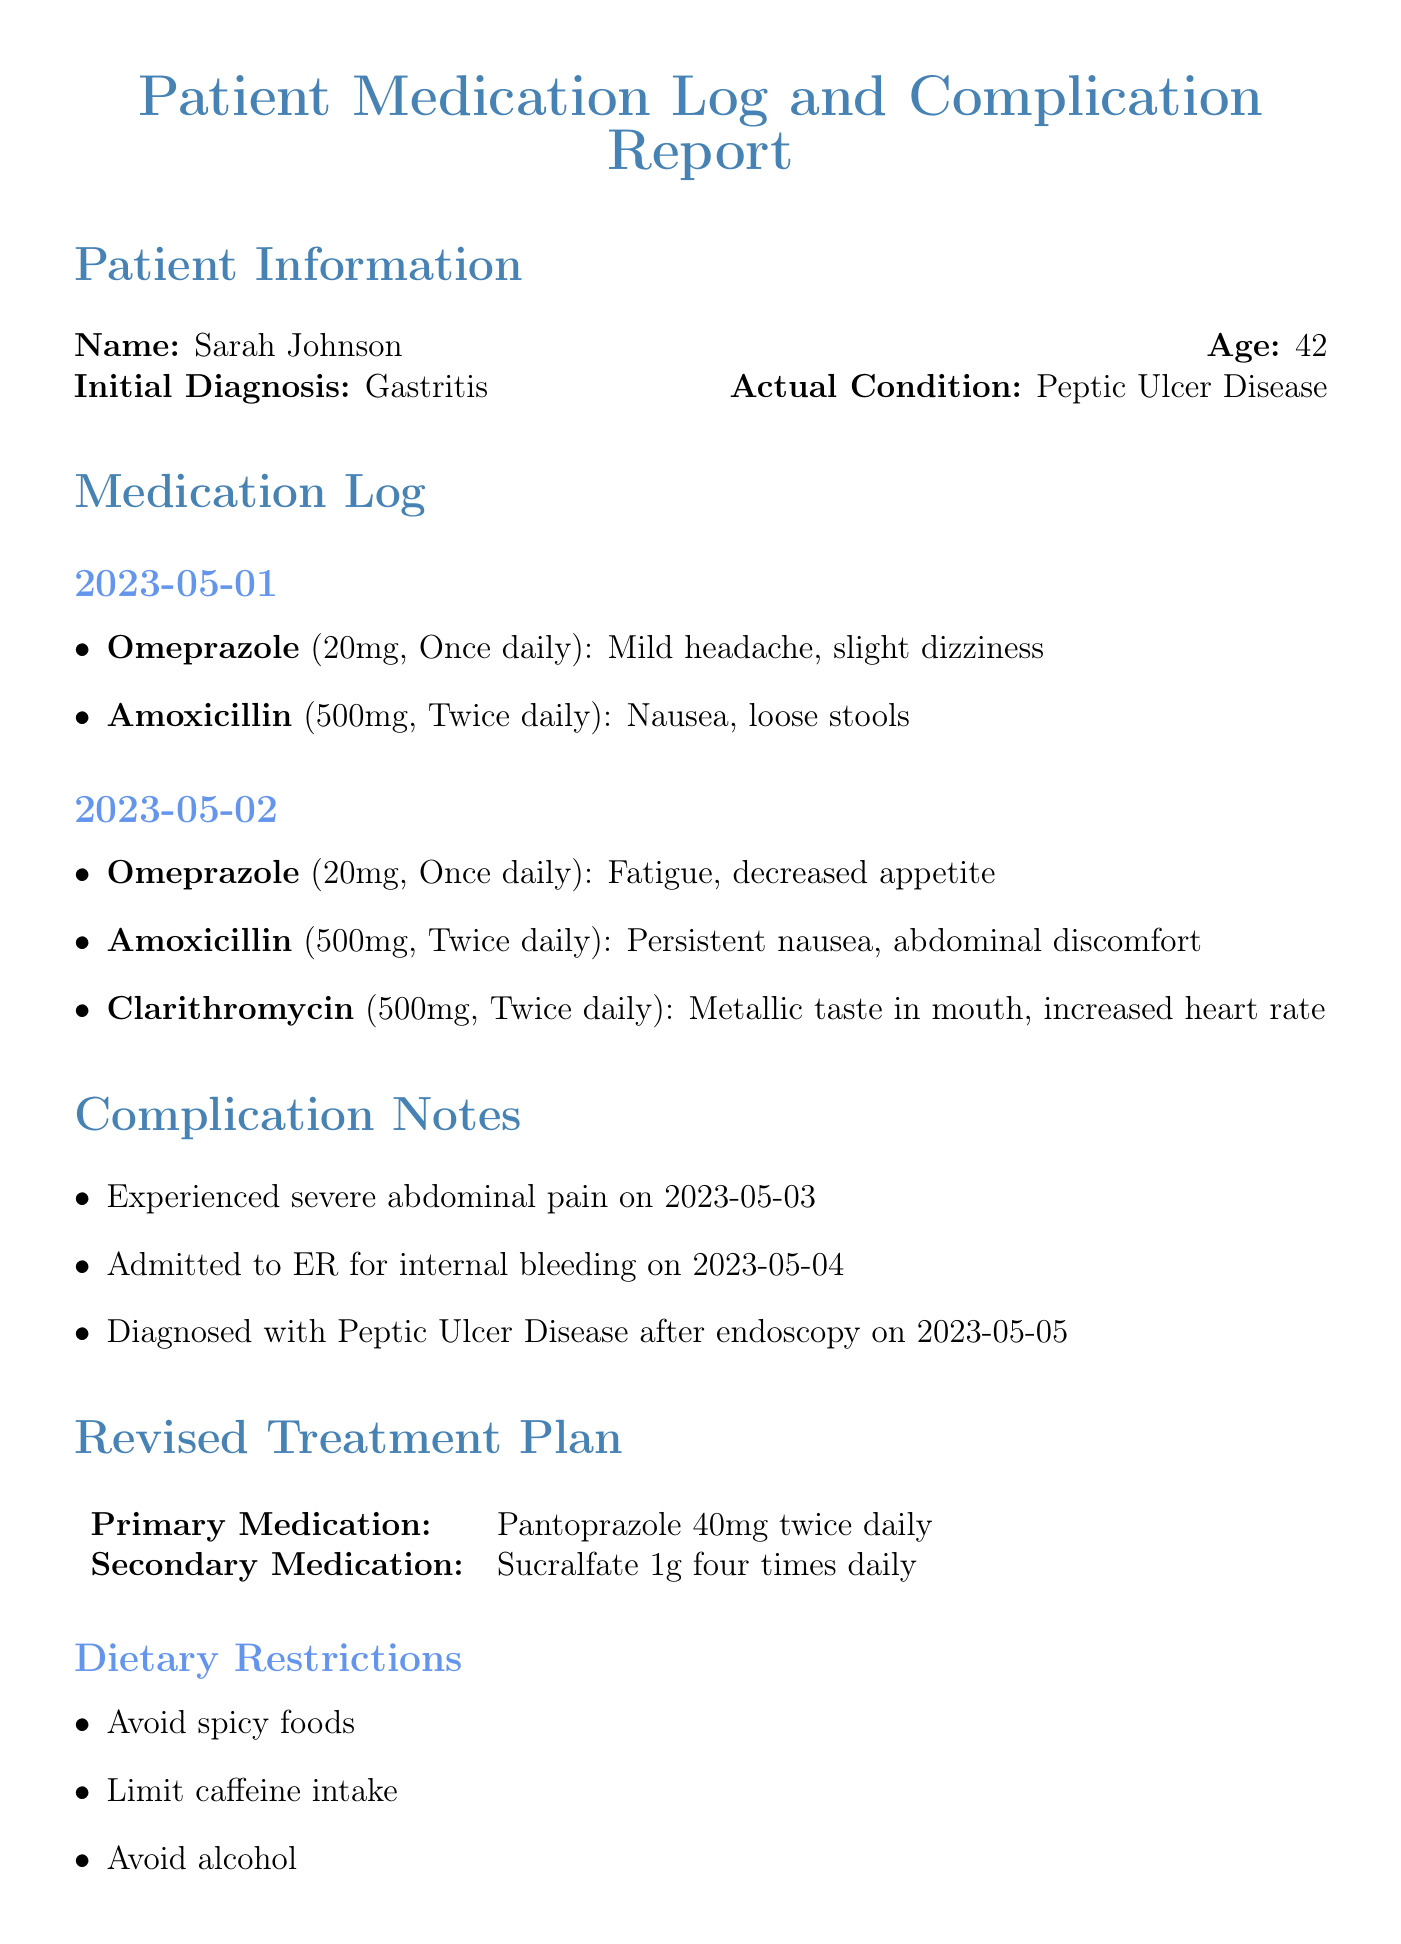What is the name of the patient? The name of the patient is explicitly mentioned in the patient information section.
Answer: Sarah Johnson What condition was the patient initially diagnosed with? The initial diagnosis is stated in the patient information section.
Answer: Gastritis What medication was taken on May 2nd that causes a metallic taste in the mouth? This requires looking at the specific side effects of the medications listed on that date.
Answer: Clarithromycin What date did the patient experience severe abdominal pain? This is found in the complication notes section, explicitly stating the date.
Answer: 2023-05-03 What is the primary medication in the revised treatment plan? This is a specific element from the revised treatment plan section, directly naming the medication.
Answer: Pantoprazole 40mg twice daily How many times daily is the secondary medication taken? The frequency of the secondary medication is specified in the revised treatment plan section.
Answer: Four times daily What dietary restriction involves caffeine? This question directly relates to the dietary restrictions listed, requiring understanding of the specific item.
Answer: Limit caffeine intake What was the diagnosis after the endoscopy? This requires connecting the complication notes and understanding the outcome after the medical procedure.
Answer: Peptic Ulcer Disease What is the date for the follow-up appointment? This is clearly mentioned in the follow-up appointment section of the document.
Answer: 2023-05-15 